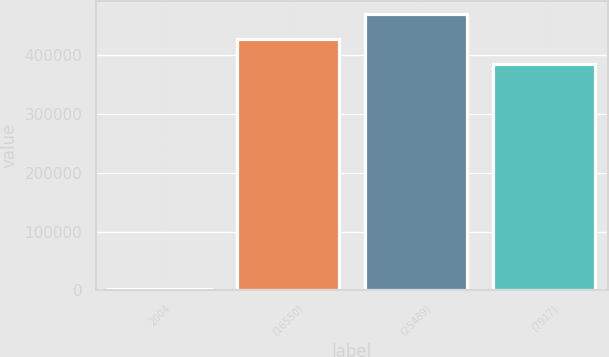<chart> <loc_0><loc_0><loc_500><loc_500><bar_chart><fcel>2004<fcel>(16550)<fcel>(25489)<fcel>(7917)<nl><fcel>2003<fcel>427488<fcel>470054<fcel>384922<nl></chart> 